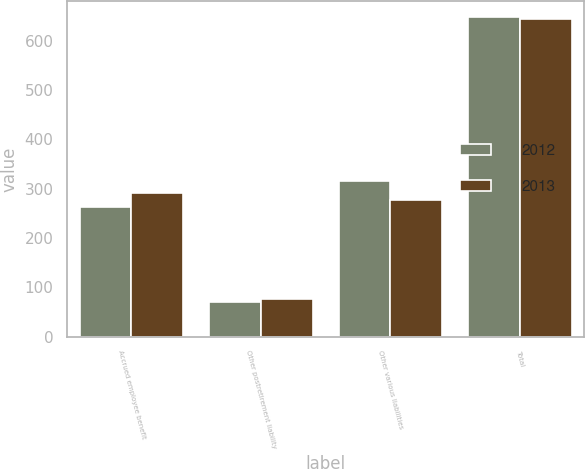Convert chart to OTSL. <chart><loc_0><loc_0><loc_500><loc_500><stacked_bar_chart><ecel><fcel>Accrued employee benefit<fcel>Other postretirement liability<fcel>Other various liabilities<fcel>Total<nl><fcel>2012<fcel>262<fcel>70.1<fcel>315.8<fcel>647.9<nl><fcel>2013<fcel>291.5<fcel>77.3<fcel>276.1<fcel>644.9<nl></chart> 